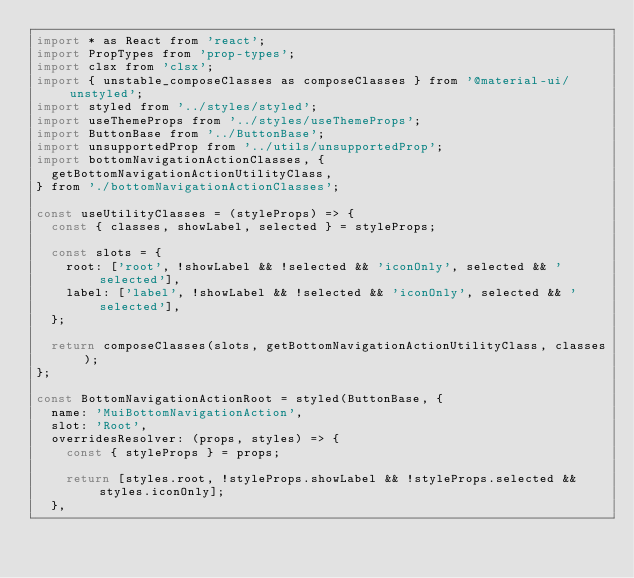<code> <loc_0><loc_0><loc_500><loc_500><_JavaScript_>import * as React from 'react';
import PropTypes from 'prop-types';
import clsx from 'clsx';
import { unstable_composeClasses as composeClasses } from '@material-ui/unstyled';
import styled from '../styles/styled';
import useThemeProps from '../styles/useThemeProps';
import ButtonBase from '../ButtonBase';
import unsupportedProp from '../utils/unsupportedProp';
import bottomNavigationActionClasses, {
  getBottomNavigationActionUtilityClass,
} from './bottomNavigationActionClasses';

const useUtilityClasses = (styleProps) => {
  const { classes, showLabel, selected } = styleProps;

  const slots = {
    root: ['root', !showLabel && !selected && 'iconOnly', selected && 'selected'],
    label: ['label', !showLabel && !selected && 'iconOnly', selected && 'selected'],
  };

  return composeClasses(slots, getBottomNavigationActionUtilityClass, classes);
};

const BottomNavigationActionRoot = styled(ButtonBase, {
  name: 'MuiBottomNavigationAction',
  slot: 'Root',
  overridesResolver: (props, styles) => {
    const { styleProps } = props;

    return [styles.root, !styleProps.showLabel && !styleProps.selected && styles.iconOnly];
  },</code> 